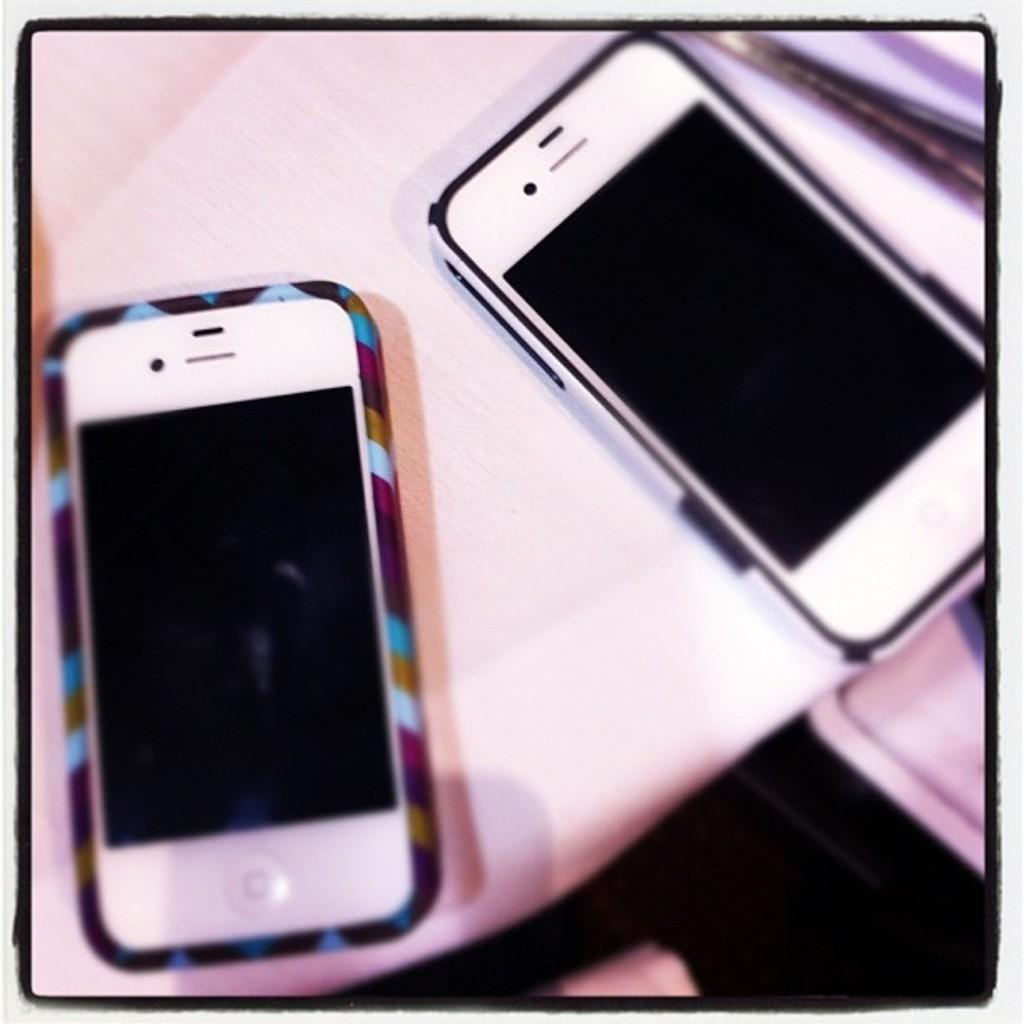What is the main subject of the image? The main subject of the image is a photo. What is depicted in the photo? The photo contains two mobiles. What is the color of the surface on which the mobiles are placed? The mobiles are on a white surface. What type of tent is visible in the image? There is no tent present in the image. What authority figure can be seen in the image? There is no authority figure present in the image. 